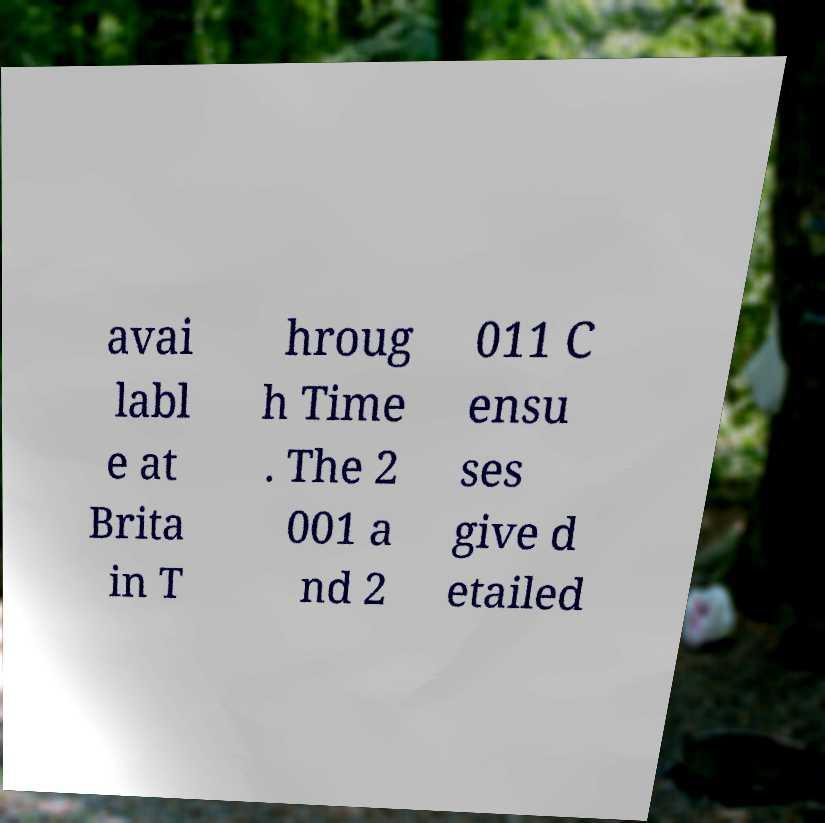Could you extract and type out the text from this image? avai labl e at Brita in T hroug h Time . The 2 001 a nd 2 011 C ensu ses give d etailed 